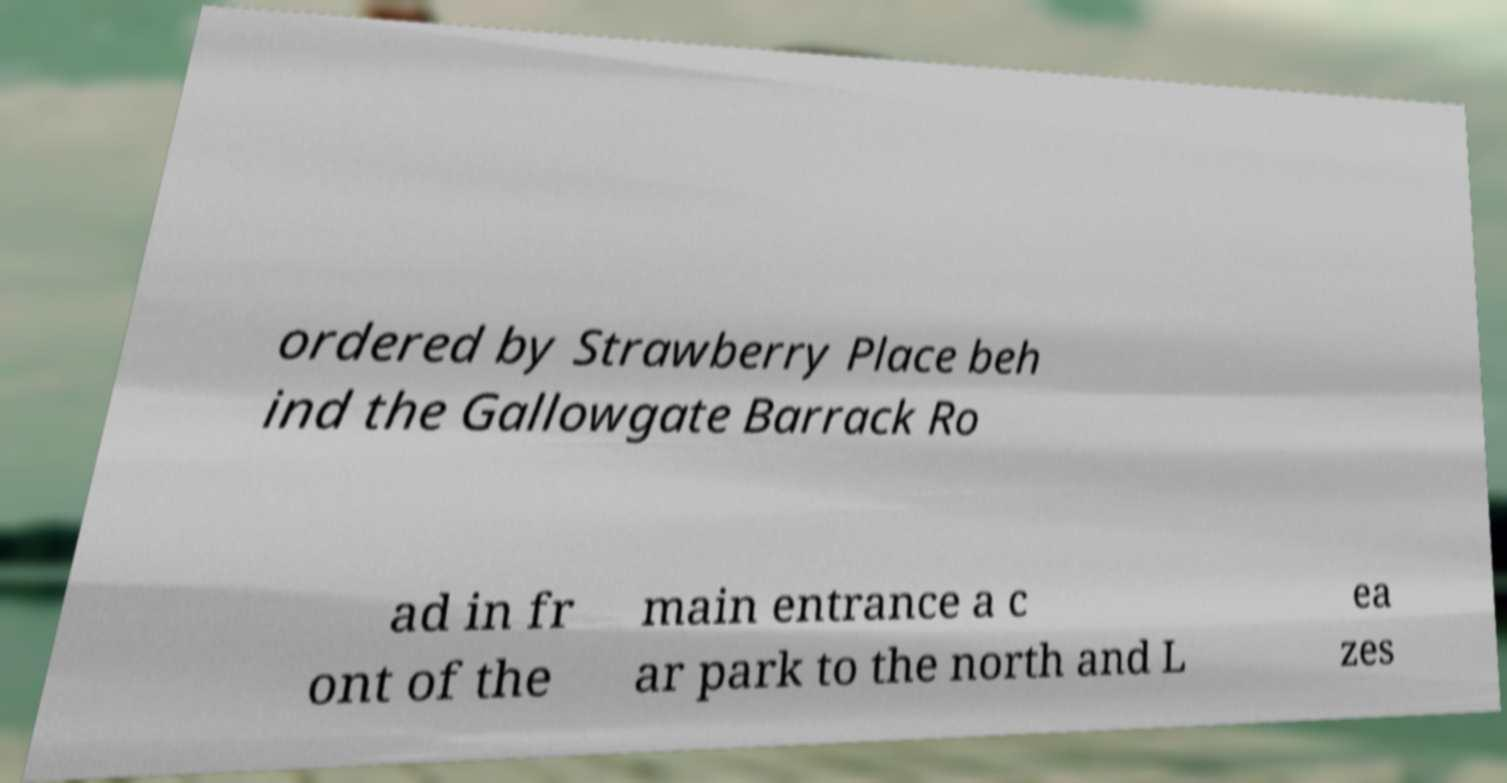Please read and relay the text visible in this image. What does it say? ordered by Strawberry Place beh ind the Gallowgate Barrack Ro ad in fr ont of the main entrance a c ar park to the north and L ea zes 